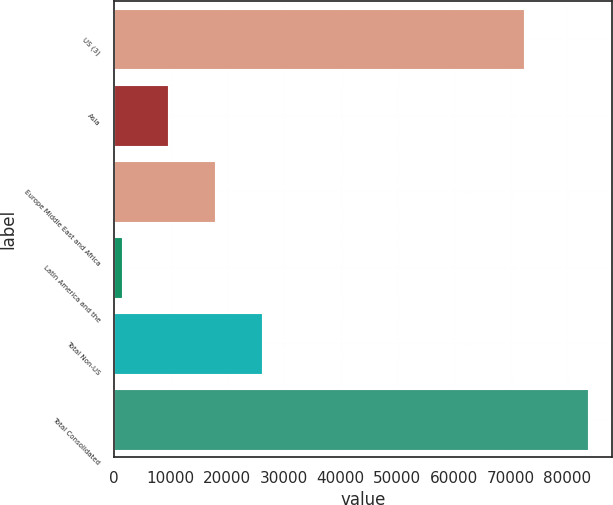Convert chart to OTSL. <chart><loc_0><loc_0><loc_500><loc_500><bar_chart><fcel>US (3)<fcel>Asia<fcel>Europe Middle East and Africa<fcel>Latin America and the<fcel>Total Non-US<fcel>Total Consolidated<nl><fcel>72418<fcel>9549.1<fcel>17788.2<fcel>1310<fcel>26027.3<fcel>83701<nl></chart> 